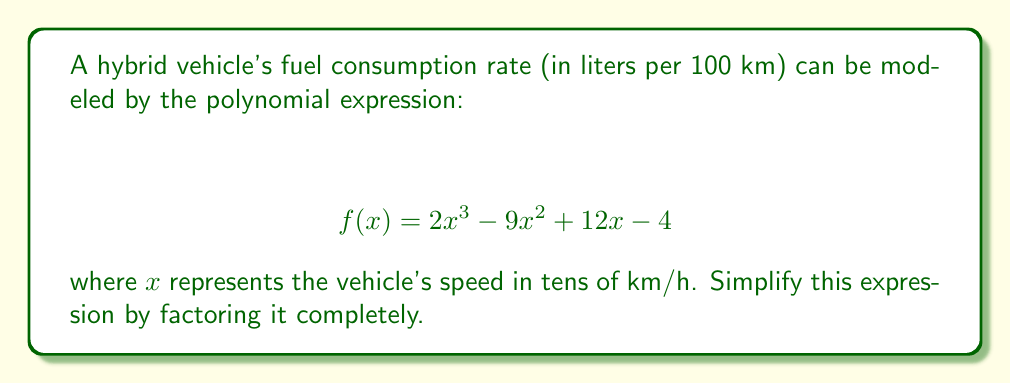Solve this math problem. To simplify this polynomial expression, we'll follow these steps:

1) First, let's check if there's a common factor for all terms:
   $2x^3 - 9x^2 + 12x - 4$
   There's no common factor for all terms.

2) Next, we'll try to factor by grouping:
   $$(2x^3 - 9x^2) + (12x - 4)$$
   $$(2x^2(x - \frac{9}{2})) + (4(3x - 1))$$

3) We can factor out $(2x - 2)$ from both groups:
   $$(2x - 2)(x^2) + (2x - 2)(2)$$
   $$(2x - 2)(x^2 + 2)$$

4) The factor $(x^2 + 2)$ cannot be factored further as it has no real roots.

5) We can rewrite $(2x - 2)$ as $2(x - 1)$

Therefore, the fully factored expression is:

$$ 2(x - 1)(x^2 + 2) $$

This factored form provides insight into the fuel consumption rate. The factor $(x - 1)$ suggests that the consumption rate changes significantly when the speed is around 10 km/h (remember $x$ is in tens of km/h). The factor $(x^2 + 2)$ indicates that the consumption rate always increases with speed, regardless of the current speed.
Answer: $$ f(x) = 2(x - 1)(x^2 + 2) $$ 